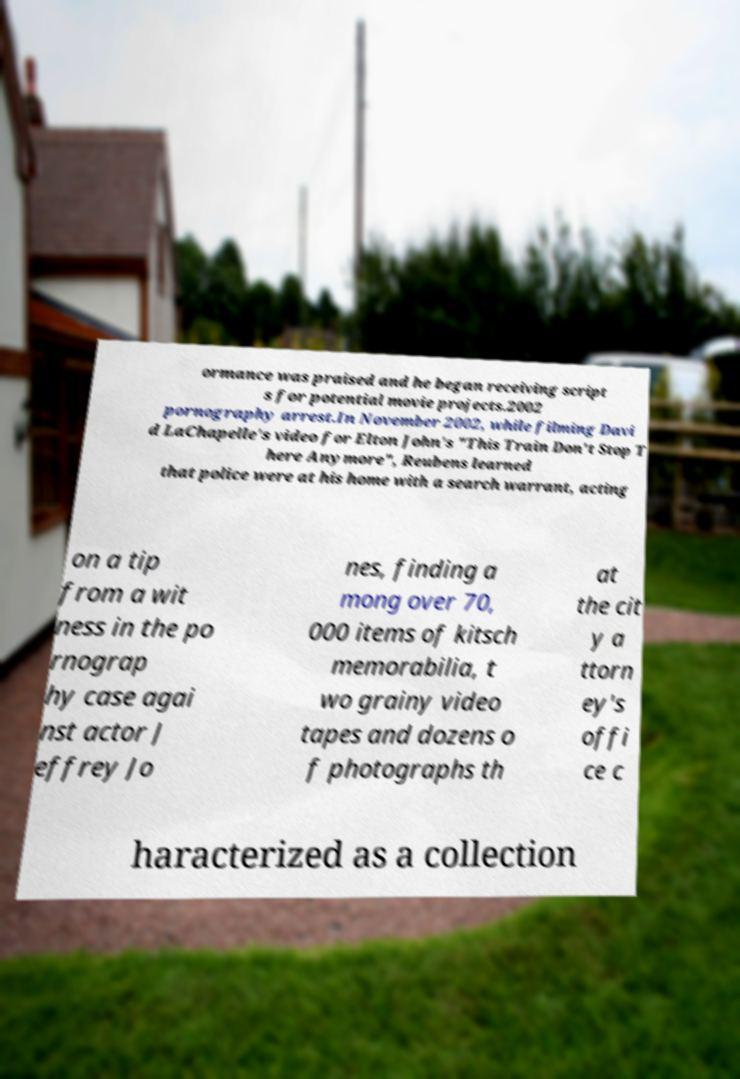Could you assist in decoding the text presented in this image and type it out clearly? ormance was praised and he began receiving script s for potential movie projects.2002 pornography arrest.In November 2002, while filming Davi d LaChapelle's video for Elton John's "This Train Don't Stop T here Anymore", Reubens learned that police were at his home with a search warrant, acting on a tip from a wit ness in the po rnograp hy case agai nst actor J effrey Jo nes, finding a mong over 70, 000 items of kitsch memorabilia, t wo grainy video tapes and dozens o f photographs th at the cit y a ttorn ey's offi ce c haracterized as a collection 